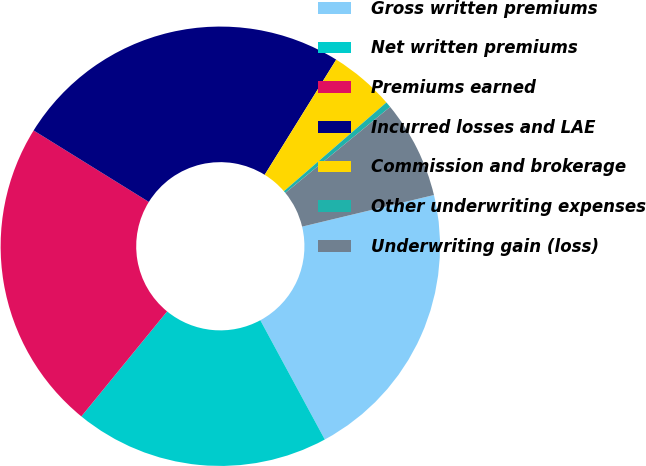<chart> <loc_0><loc_0><loc_500><loc_500><pie_chart><fcel>Gross written premiums<fcel>Net written premiums<fcel>Premiums earned<fcel>Incurred losses and LAE<fcel>Commission and brokerage<fcel>Other underwriting expenses<fcel>Underwriting gain (loss)<nl><fcel>20.86%<fcel>18.79%<fcel>22.94%<fcel>25.01%<fcel>4.8%<fcel>0.42%<fcel>7.19%<nl></chart> 